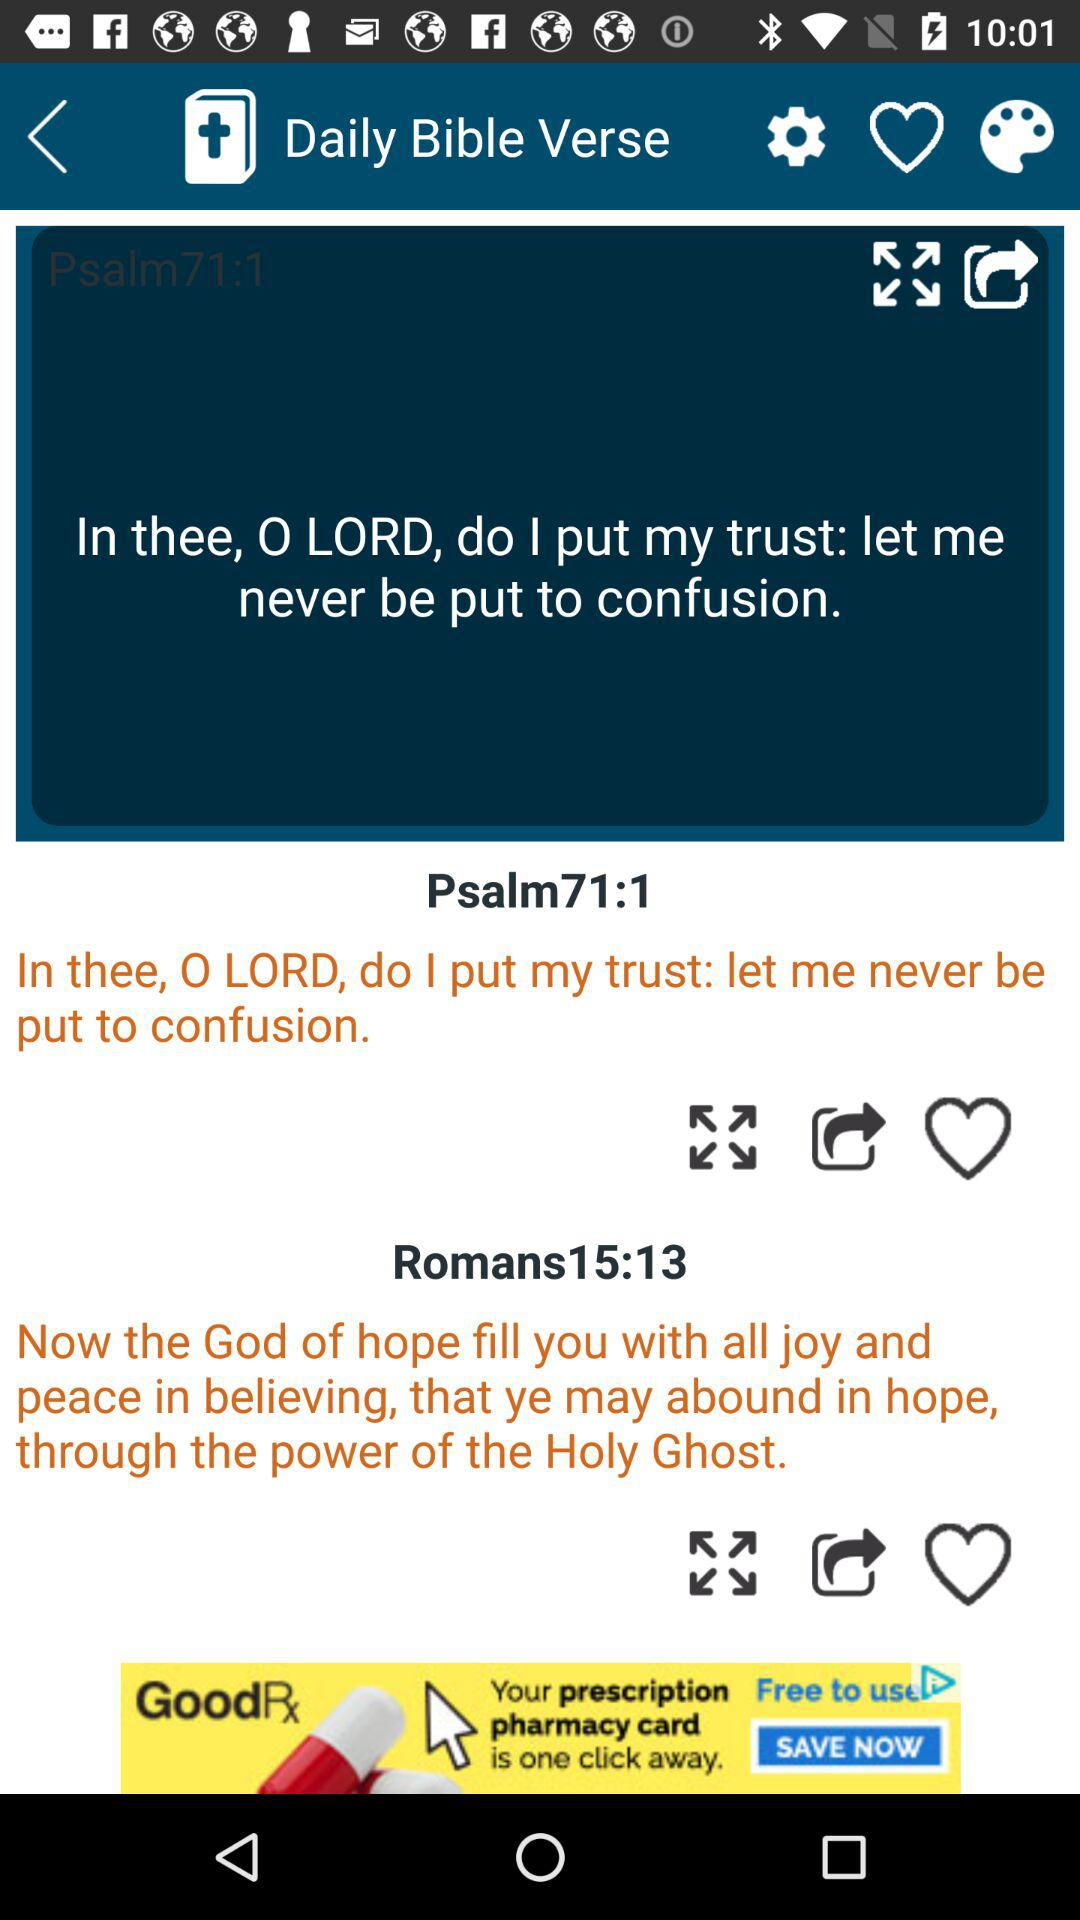What is the name of the application? The name of the application is "Daily Bible Verse". 